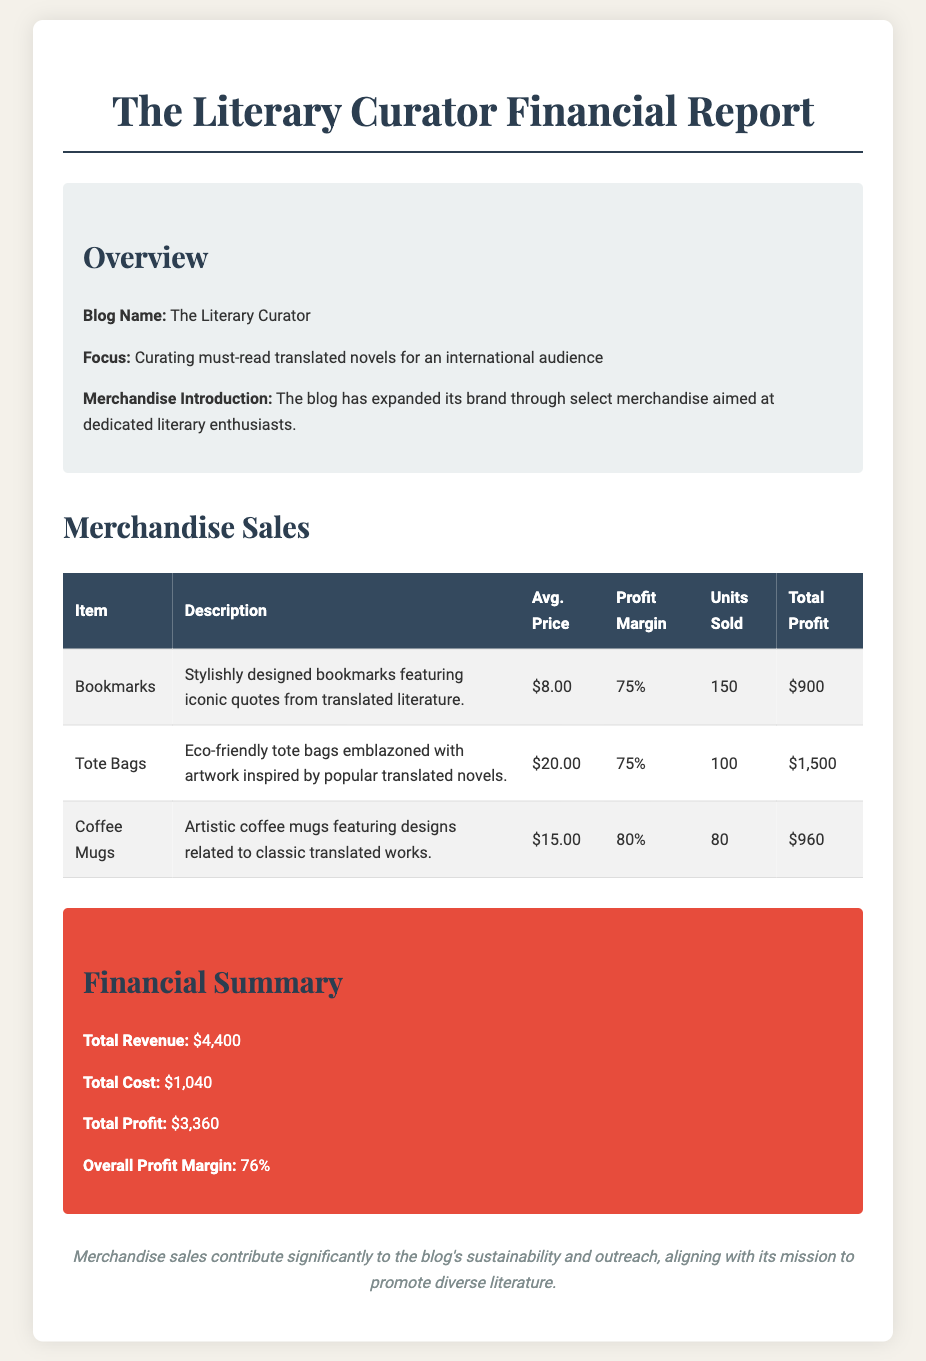what is the blog name? The blog name is stated in the Overview section of the document.
Answer: The Literary Curator what is the average price of a tote bag? The average price of a tote bag is listed in the Merchandise Sales table under the Avg. Price column.
Answer: $20.00 how many units of bookmarks were sold? The number of units sold for bookmarks is provided in the Merchandise Sales table under the Units Sold column.
Answer: 150 what is the profit margin for coffee mugs? The profit margin for coffee mugs is found in the Merchandise Sales table under the Profit Margin column.
Answer: 80% what is the total profit reported? The total profit is mentioned in the Financial Summary section of the document.
Answer: $3,360 how much revenue was generated from tote bag sales? Revenue from tote bag sales can be calculated by multiplying the average price by the units sold. This calculation is derived from the information in the Merchandise Sales table.
Answer: $2,000 what is the overall profit margin for the merchandise? The overall profit margin is stated in the Financial Summary section of the document.
Answer: 76% what type of merchandise does the blog offer? The document provides descriptions of merchandise items in the table, detailing the type of items sold.
Answer: Bookmarks, Tote Bags, Coffee Mugs how does merchandise sales impact the blog? The conclusion at the end of the document addresses the significance of merchandise sales to the blog.
Answer: Sustainability and outreach 